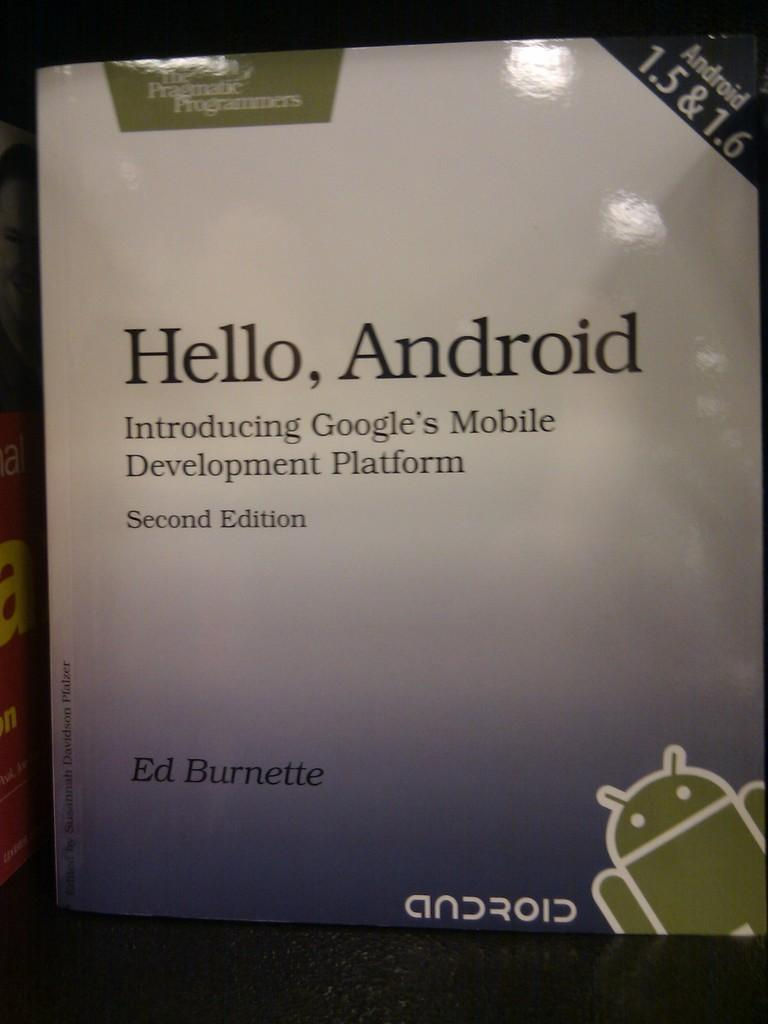<image>
Relay a brief, clear account of the picture shown. A book by Ed Burnette is called Hello, Android 